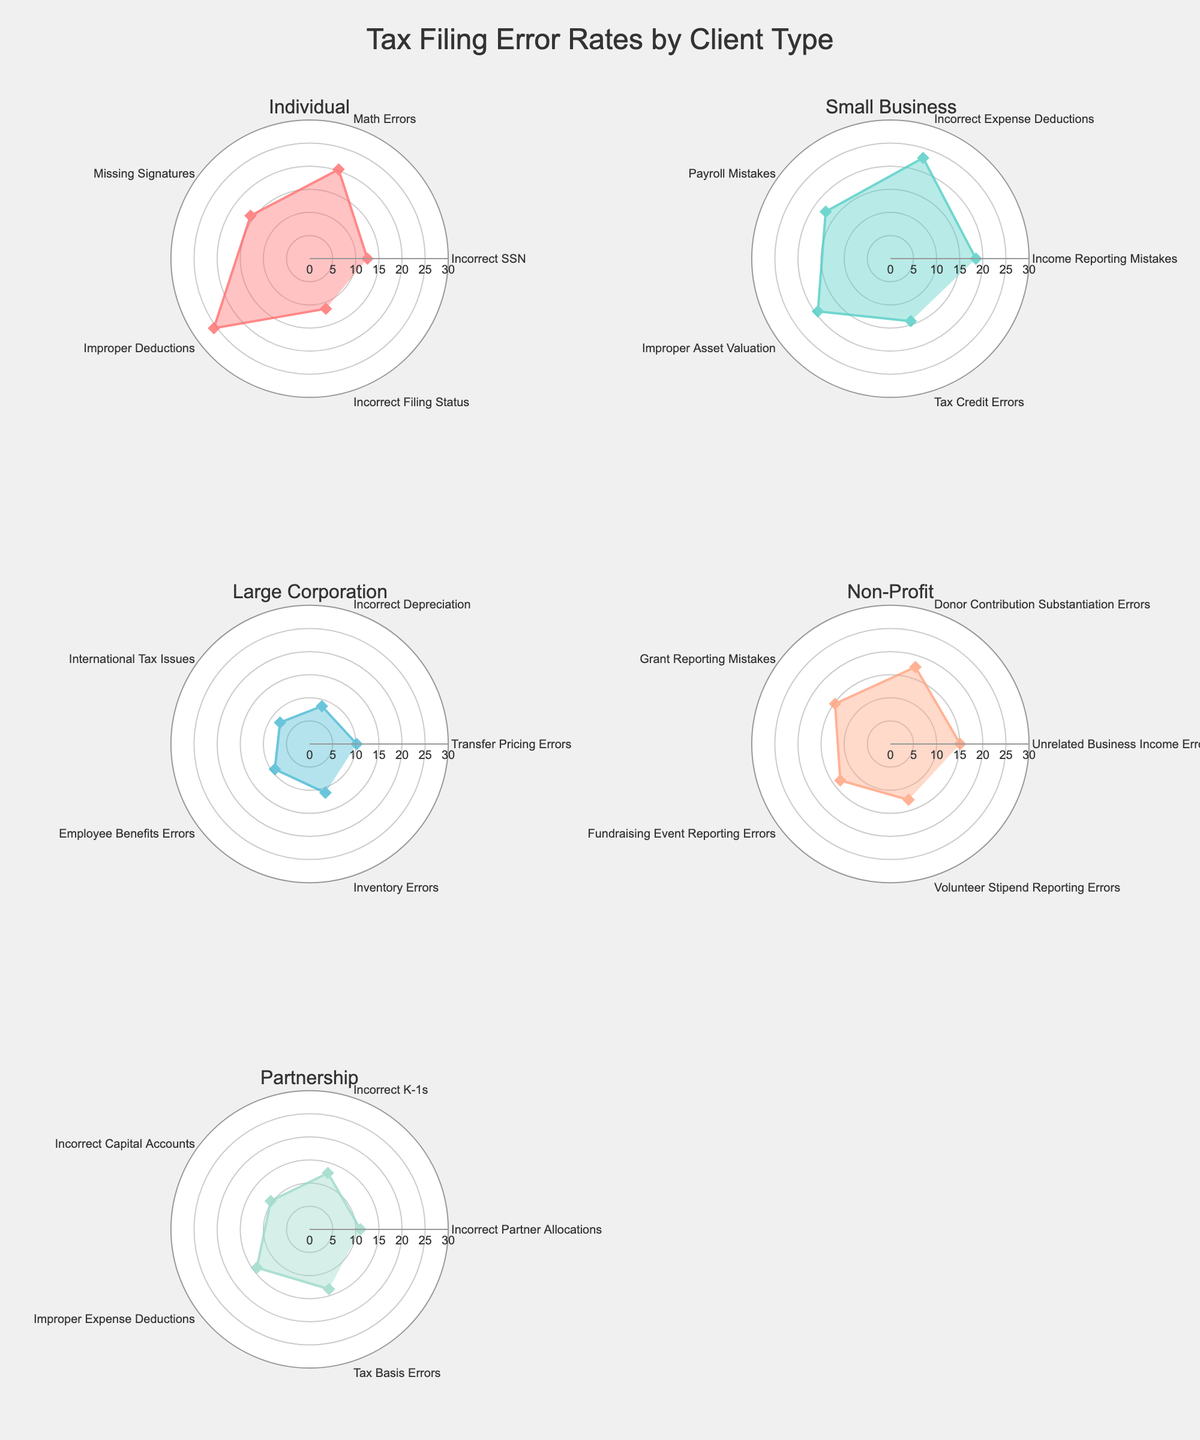What's the title of the figure? The title of the figure is prominently displayed at the top center. The text reads: "Tax Filing Error Rates by Client Type".
Answer: Tax Filing Error Rates by Client Type Which client type has the highest tax filing error rate? To find the client type with the highest error rate, compare the maximum percentage values across all subplots. Individual has the highest error rate, "Improper Deductions" at 25.6%.
Answer: Individual How many types of tax filing errors are there for Partnerships? Each subplot represents a client type with specific error types as data points. The Partnership subplot has 5 distinct error types.
Answer: 5 What is the average error rate for Small Businesses? Sum up all error rates for Small Businesses and divide by 5. The total is 18.5 + 22.9 + 17.3 + 19.4 + 14.2 = 92.3. Average is 92.3/5 = 18.46.
Answer: 18.46 Which error type for Non-Profits is the highest? Examine the Non-Profit subplot and identify the error type with the highest percentage. It's "Donor Contribution Substantiation Errors" at 17.5%.
Answer: Donor Contribution Substantiation Errors Compare the error rates of "Incorrect SSN" in Individuals with "Incorrect Partner Allocations" in Partnerships. Which one is higher? "Incorrect SSN" in Individuals is 12.5%, while "Incorrect Partner Allocations" in Partnerships is 11%. Thus, the former is higher.
Answer: Incorrect SSN Which client type has the lowest average error rate? Calculate the average error rates for all client types and compare them. Large Corporation has the lowest average with [(10.2 + 8.6 + 7.9 + 9.3 + 11.1) / 5] = 9.42.
Answer: Large Corporation What is the second highest error rate for Large Corporations? First, list all error rates for Large Corporations, then find the second highest. The highest is 11.1% for "Inventory Errors", and the second highest is 10.2% for "Transfer Pricing Errors".
Answer: Transfer Pricing Errors Is the error rate for "Improper Deductions" in Individuals higher than any error rate in Large Corporations? "Improper Deductions" in Individuals is 25.6%, while the highest rate in Large Corporations is 11.1%. Therefore, it is higher.
Answer: Yes 